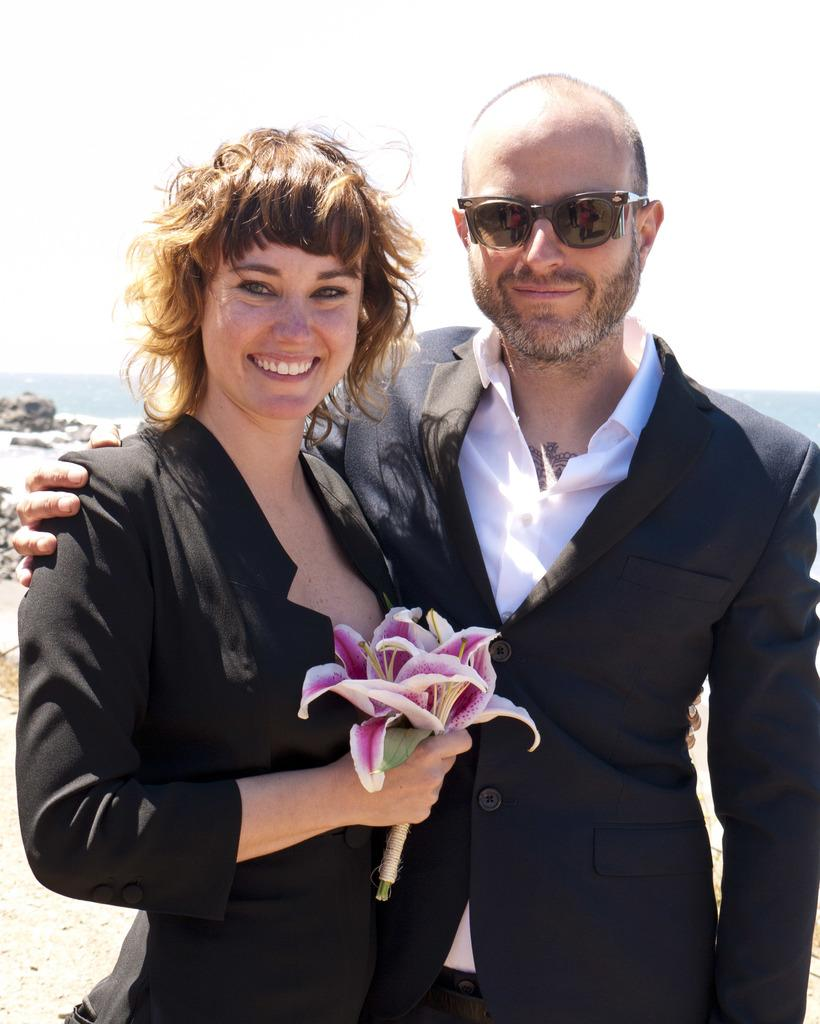Who is the main subject in the image? There is a woman in the image. What is the woman holding in the image? The woman is holding flowers. Where is the woman located in the image? The woman is standing in the middle of the image. Who else is present in the image? There is a man in the image. Where is the man located in the image? The man is standing on the right side of the image. What is the man wearing in the image? The man is wearing a black coat. What type of disease can be seen affecting the flowers in the image? There is no disease affecting the flowers in the image; they appear to be healthy. What type of hook is the man using to hold the flowers in the image? There is no hook present in the image; the woman is holding the flowers. 